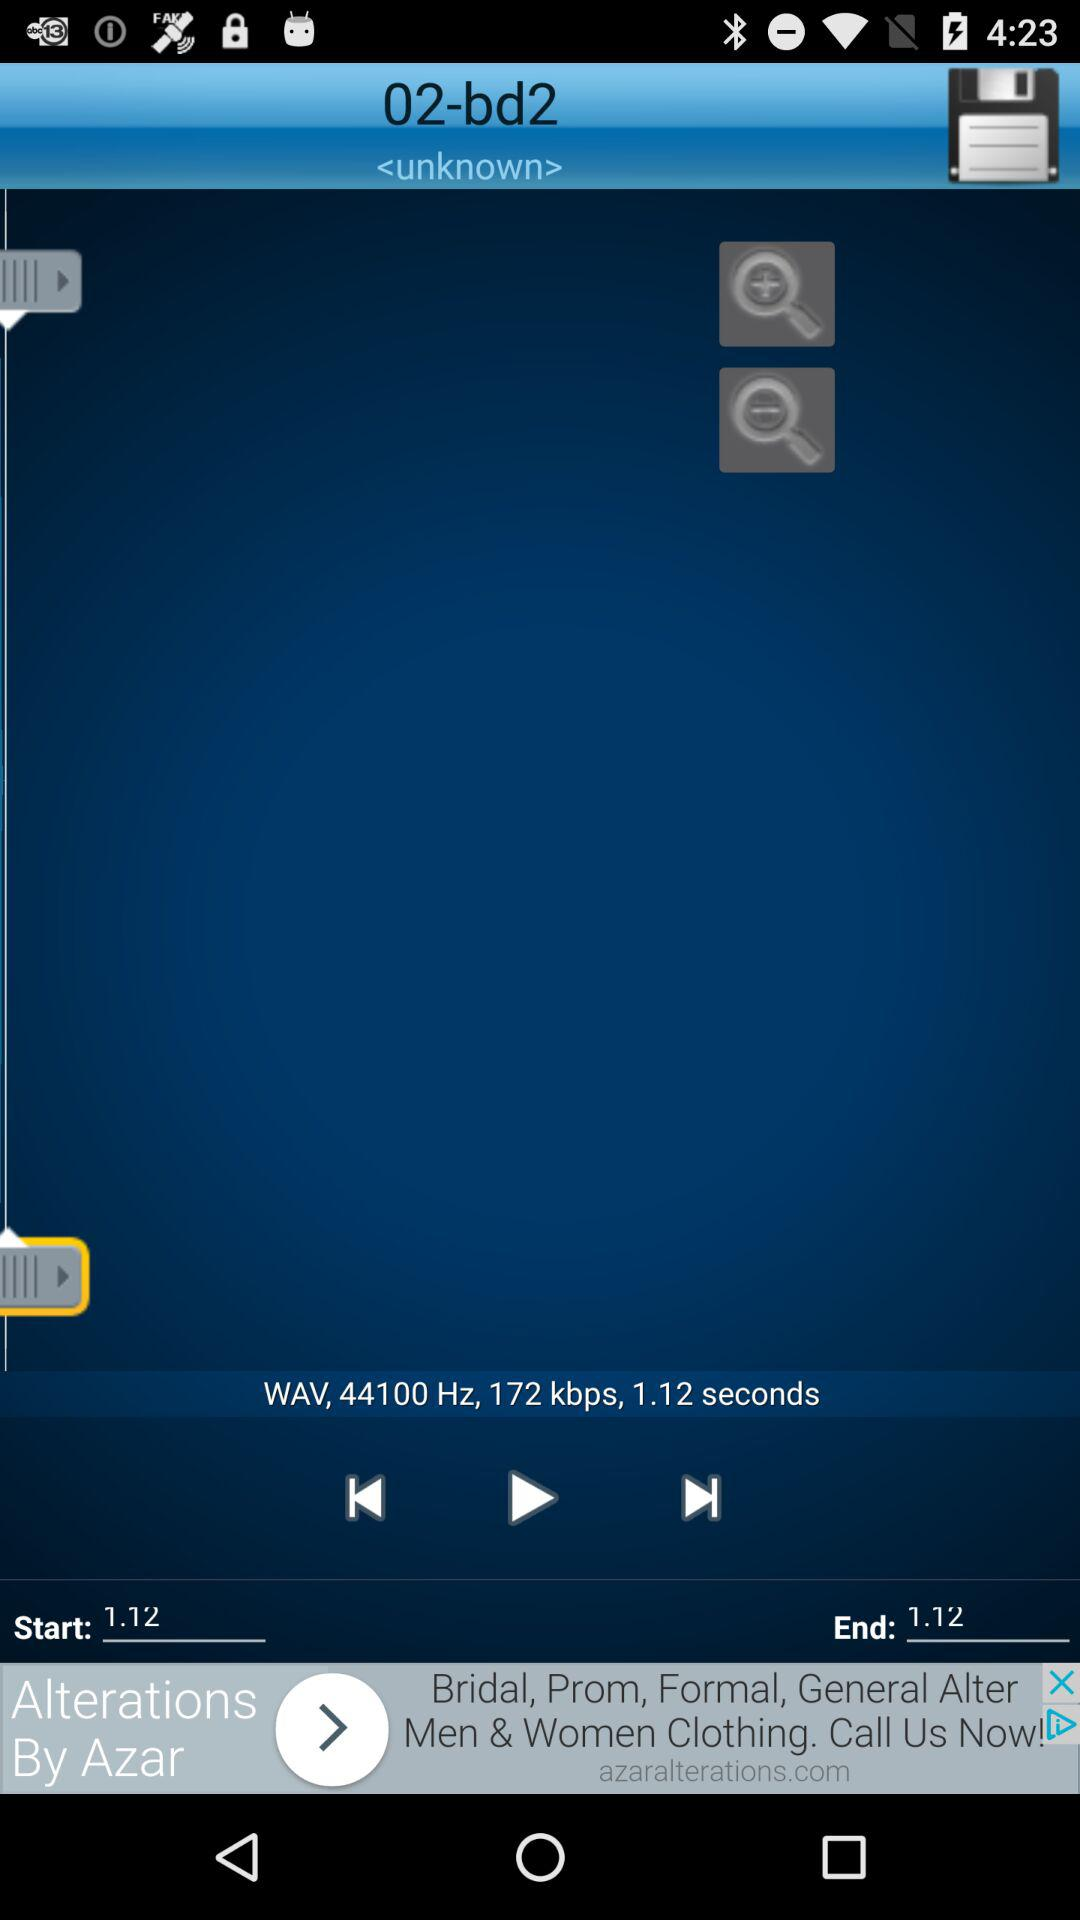Which song is currently playing? The currently playing is 02-bd2. 